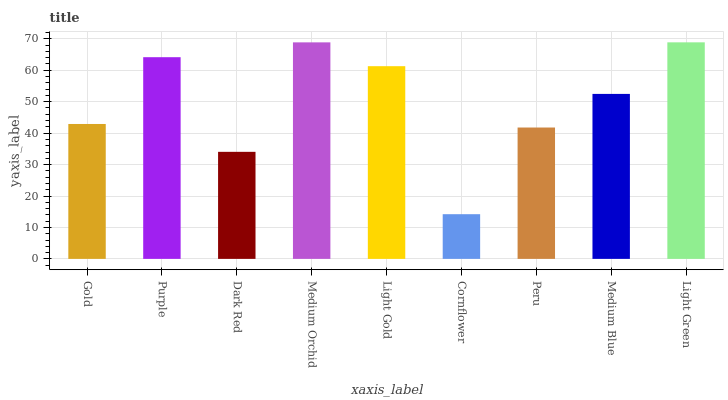Is Purple the minimum?
Answer yes or no. No. Is Purple the maximum?
Answer yes or no. No. Is Purple greater than Gold?
Answer yes or no. Yes. Is Gold less than Purple?
Answer yes or no. Yes. Is Gold greater than Purple?
Answer yes or no. No. Is Purple less than Gold?
Answer yes or no. No. Is Medium Blue the high median?
Answer yes or no. Yes. Is Medium Blue the low median?
Answer yes or no. Yes. Is Purple the high median?
Answer yes or no. No. Is Dark Red the low median?
Answer yes or no. No. 